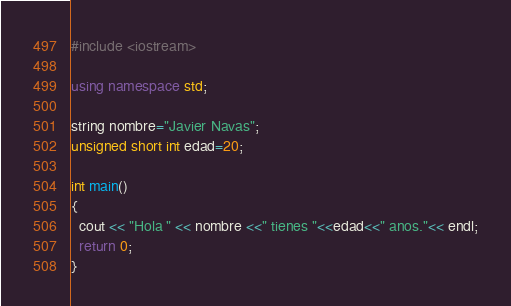Convert code to text. <code><loc_0><loc_0><loc_500><loc_500><_C++_>#include <iostream>
 
using namespace std;
 
string nombre="Javier Navas";
unsigned short int edad=20;
 
int main()
{
  cout << "Hola " << nombre <<" tienes "<<edad<<" anos."<< endl;
  return 0;
}
</code> 